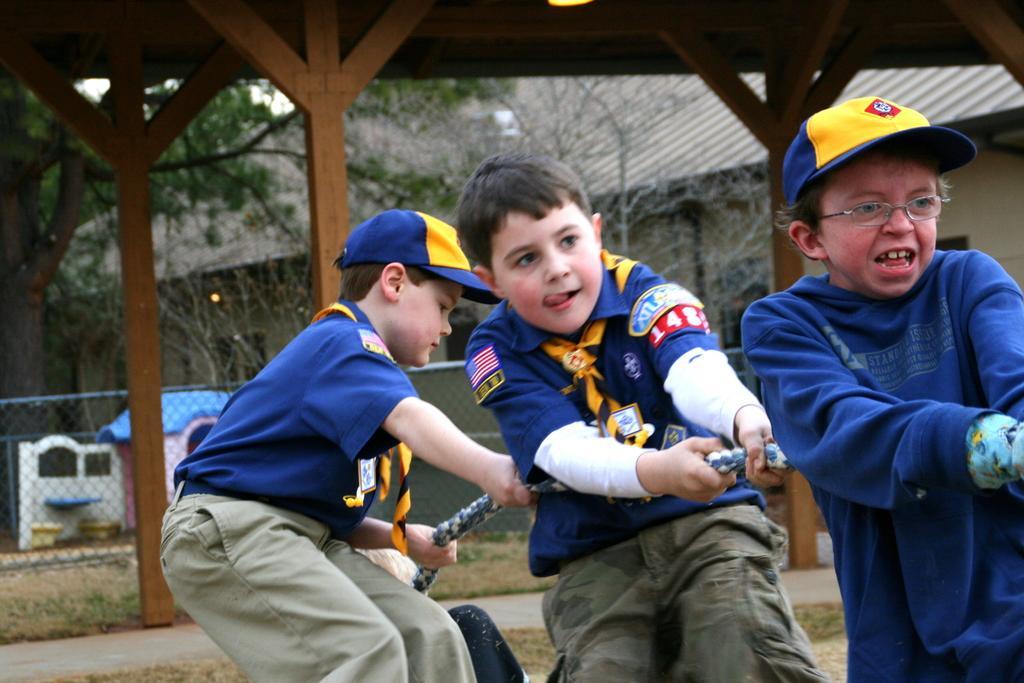How would you summarize this image in a sentence or two? In this image I can see three people are holding a rope. They are wearing ash,blue and yellow color dresses. Back I can see few sheds,net fencing,trees and few objects on the surface. 